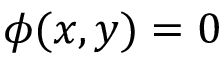Convert formula to latex. <formula><loc_0><loc_0><loc_500><loc_500>\phi ( x , y ) = 0</formula> 